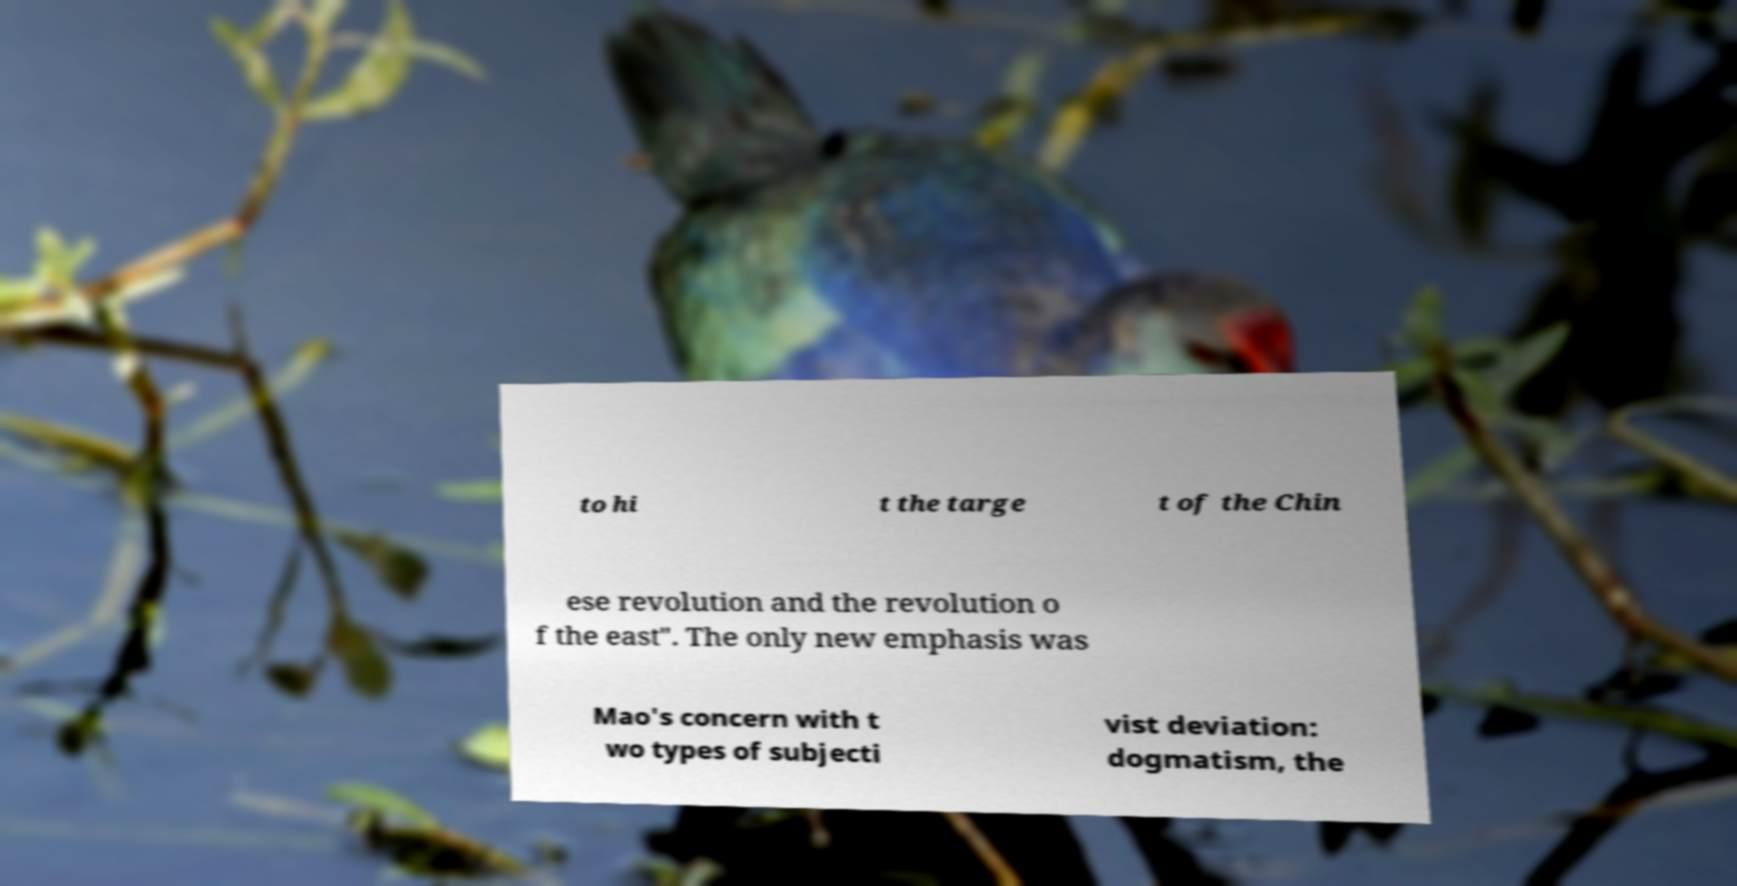For documentation purposes, I need the text within this image transcribed. Could you provide that? to hi t the targe t of the Chin ese revolution and the revolution o f the east". The only new emphasis was Mao's concern with t wo types of subjecti vist deviation: dogmatism, the 